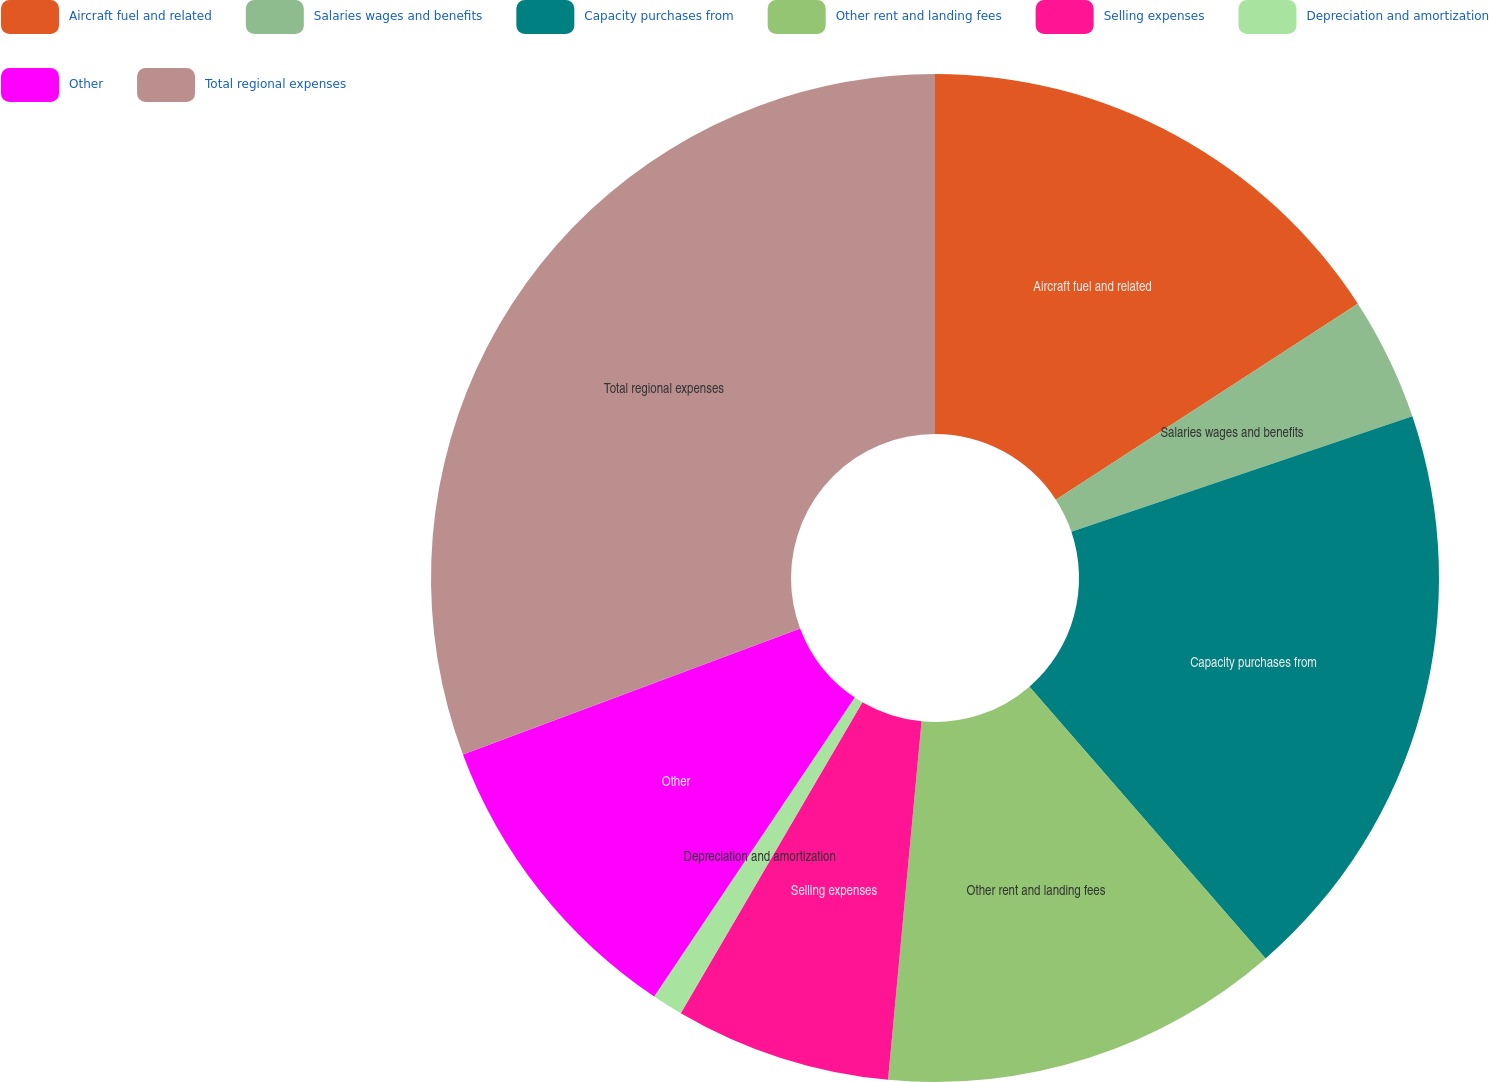<chart> <loc_0><loc_0><loc_500><loc_500><pie_chart><fcel>Aircraft fuel and related<fcel>Salaries wages and benefits<fcel>Capacity purchases from<fcel>Other rent and landing fees<fcel>Selling expenses<fcel>Depreciation and amortization<fcel>Other<fcel>Total regional expenses<nl><fcel>15.84%<fcel>3.96%<fcel>18.81%<fcel>12.87%<fcel>6.93%<fcel>0.99%<fcel>9.9%<fcel>30.69%<nl></chart> 